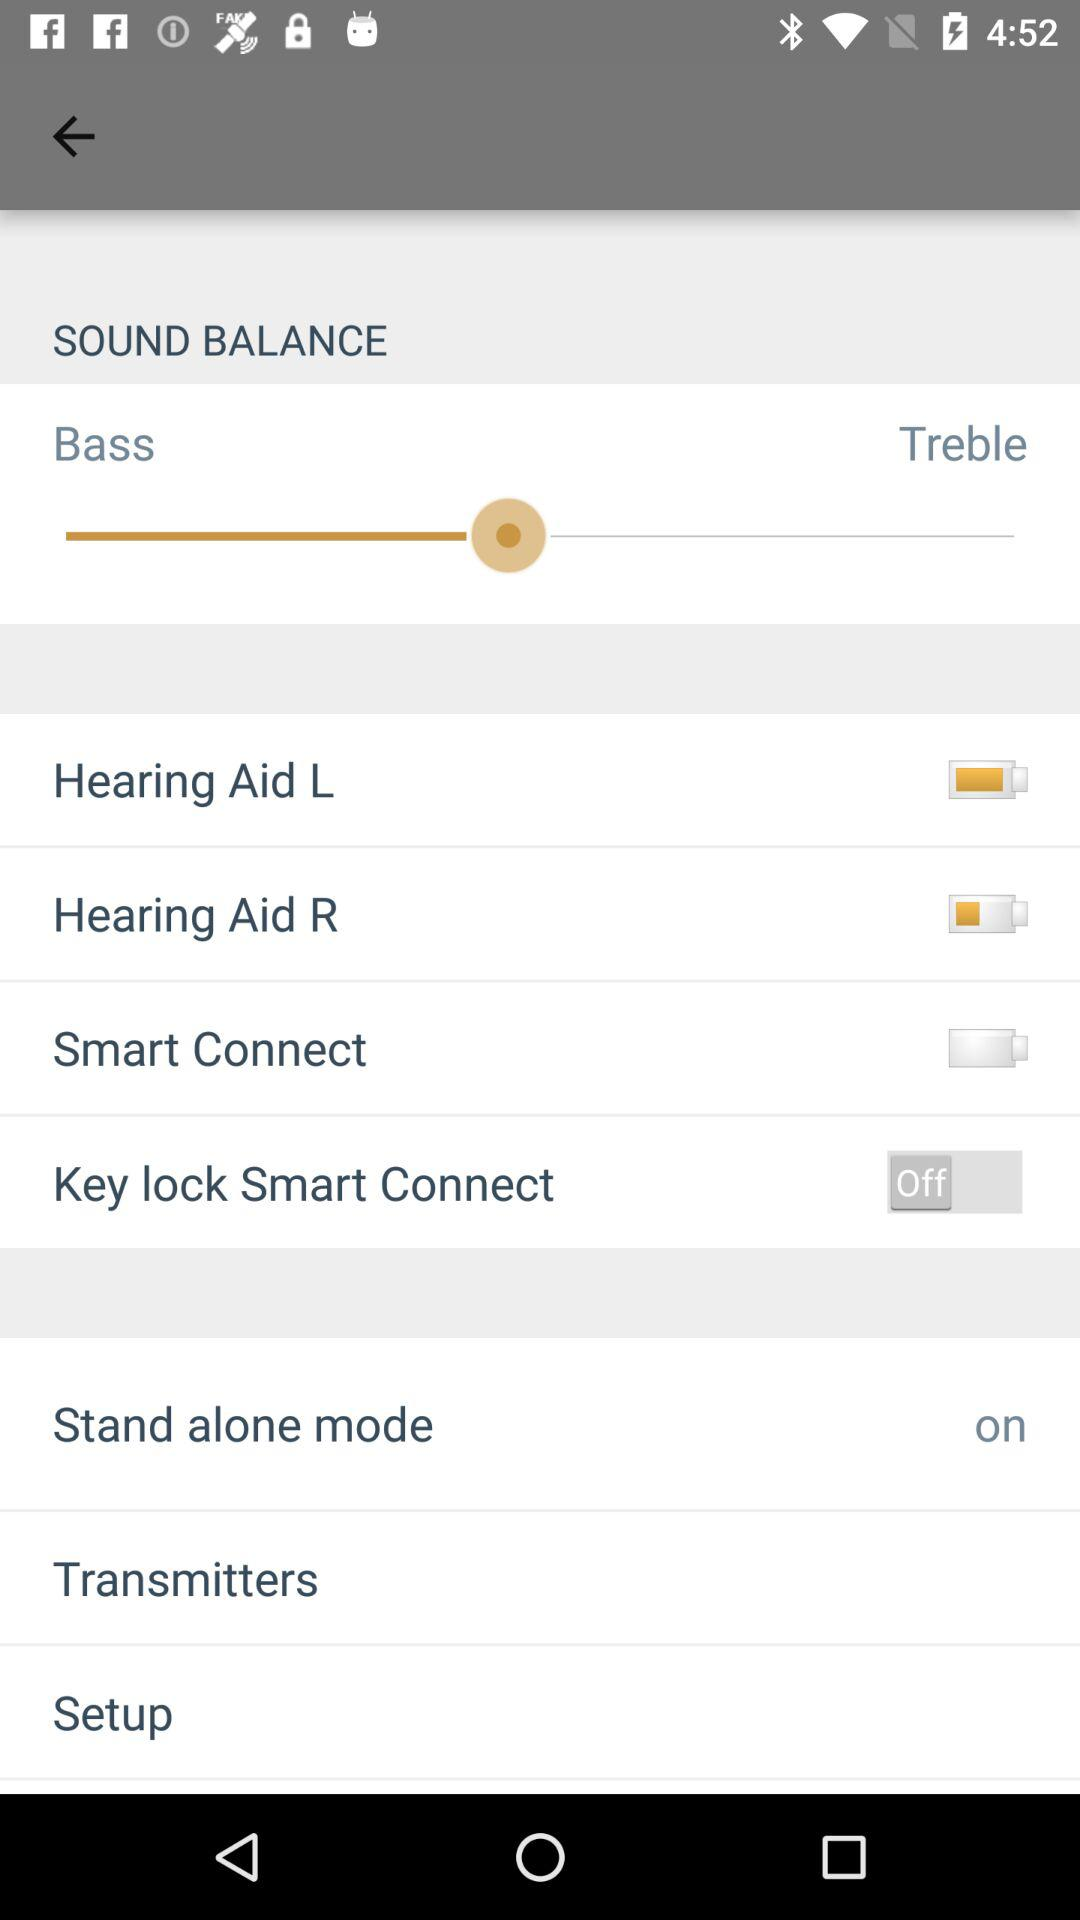What's the status of "Key lock Smart Connect"? The status is "off". 